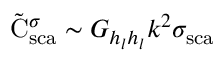Convert formula to latex. <formula><loc_0><loc_0><loc_500><loc_500>\tilde { C } _ { s c a } ^ { \sigma } \sim G _ { h _ { l } h _ { l } } k ^ { 2 } { \sigma } _ { s c a }</formula> 